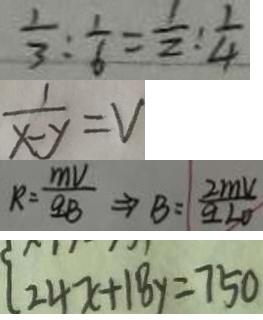Convert formula to latex. <formula><loc_0><loc_0><loc_500><loc_500>\frac { 1 } { 3 } : \frac { 1 } { 6 } = \frac { 1 } { 2 } : \frac { 1 } { 4 } 
 \frac { 1 } { x - y } = V 
 R = \frac { m V } { q B } \Rightarrow B = \frac { 2 m v } { q 3 0 } 
 2 4 x + 1 8 y = 7 5 0</formula> 